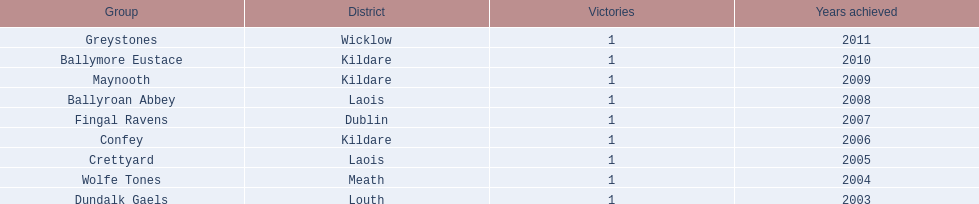In which county were the most wins recorded? Kildare. 